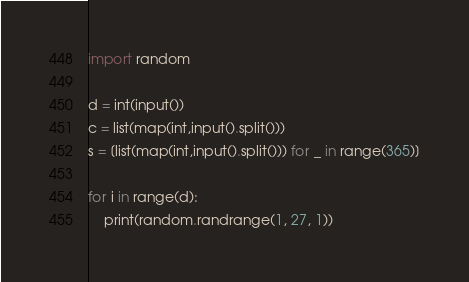Convert code to text. <code><loc_0><loc_0><loc_500><loc_500><_Python_>import random

d = int(input())
c = list(map(int,input().split()))
s = [list(map(int,input().split())) for _ in range(365)]

for i in range(d):
    print(random.randrange(1, 27, 1))</code> 